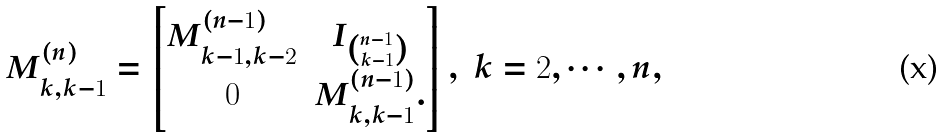<formula> <loc_0><loc_0><loc_500><loc_500>M ^ { ( n ) } _ { k , k - 1 } = \begin{bmatrix} M ^ { ( n - 1 ) } _ { k - 1 , k - 2 } & I _ { \binom { n - 1 } { k - 1 } } \\ 0 & M ^ { ( n - 1 ) } _ { k , k - 1 } . \end{bmatrix} , \ k = 2 , \cdots , n ,</formula> 